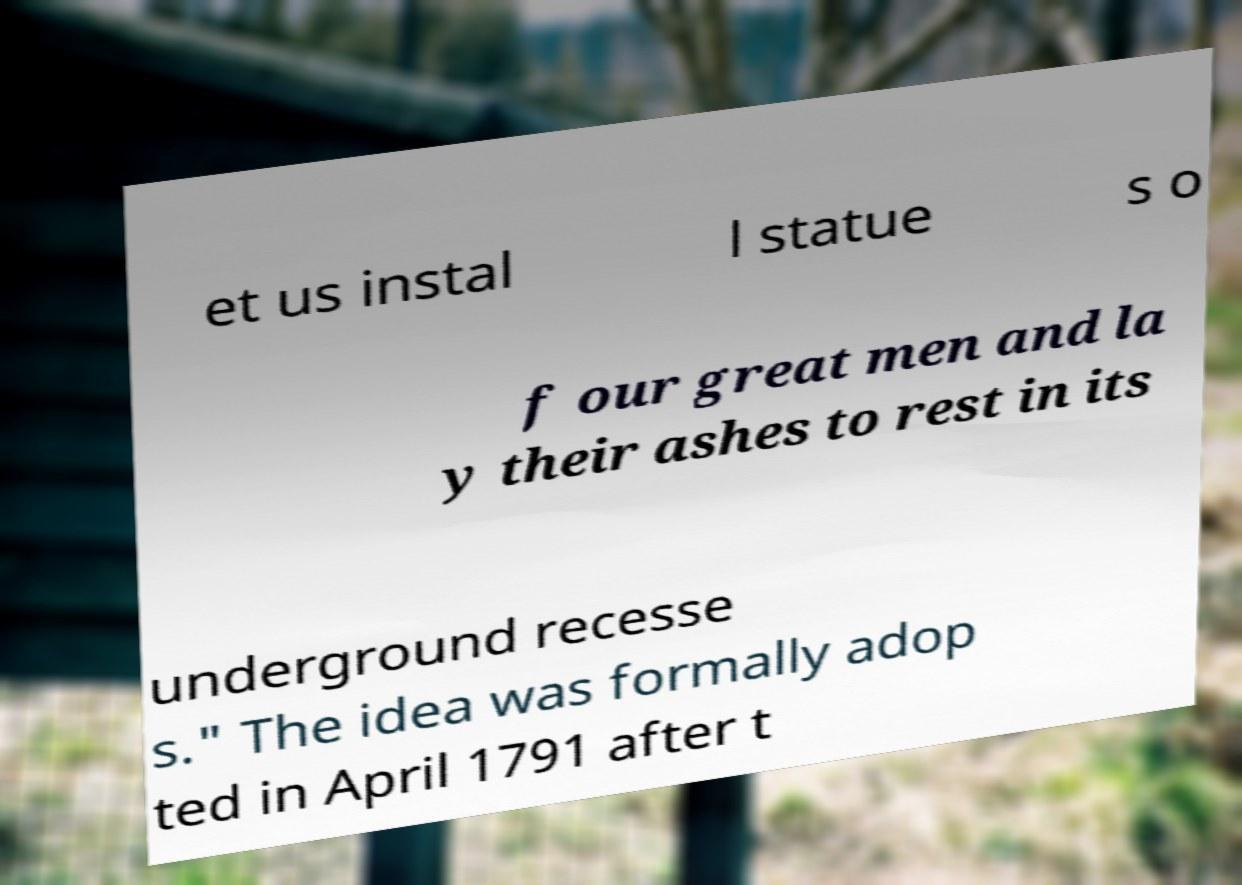Can you accurately transcribe the text from the provided image for me? et us instal l statue s o f our great men and la y their ashes to rest in its underground recesse s." The idea was formally adop ted in April 1791 after t 